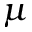<formula> <loc_0><loc_0><loc_500><loc_500>\mu</formula> 